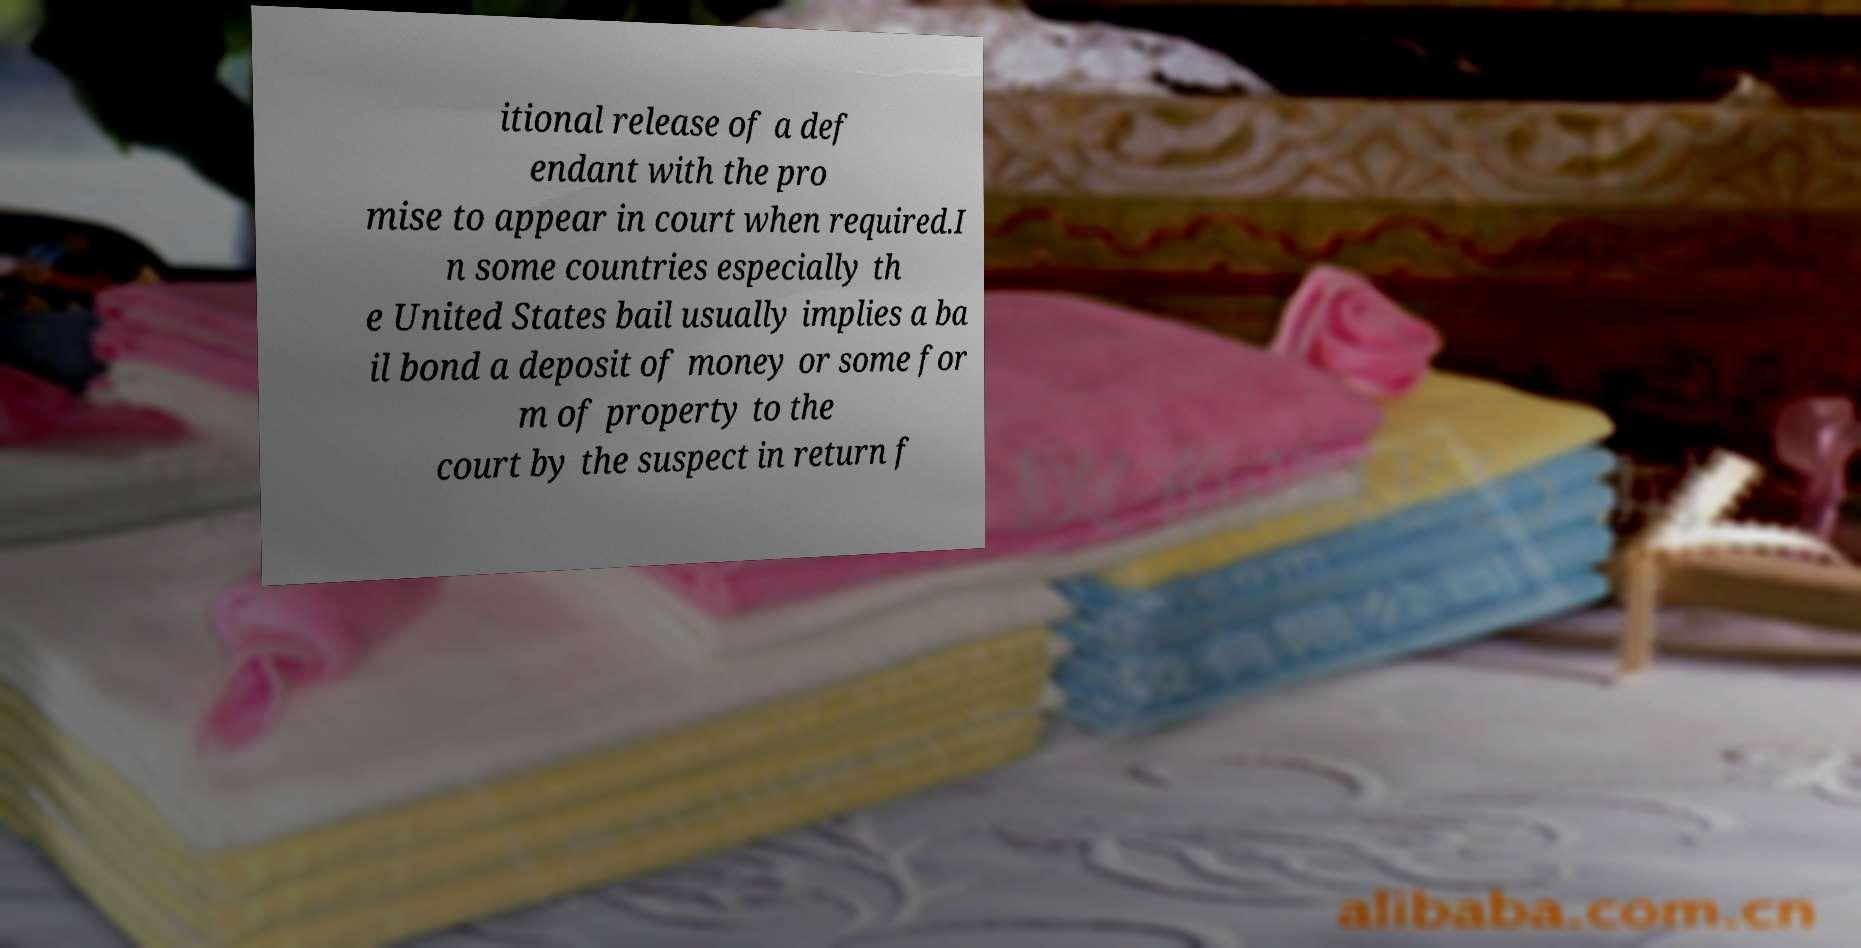I need the written content from this picture converted into text. Can you do that? itional release of a def endant with the pro mise to appear in court when required.I n some countries especially th e United States bail usually implies a ba il bond a deposit of money or some for m of property to the court by the suspect in return f 